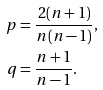Convert formula to latex. <formula><loc_0><loc_0><loc_500><loc_500>p & = \frac { 2 ( n + 1 ) } { n ( n - 1 ) } , \\ q & = \frac { n + 1 } { n - 1 } .</formula> 